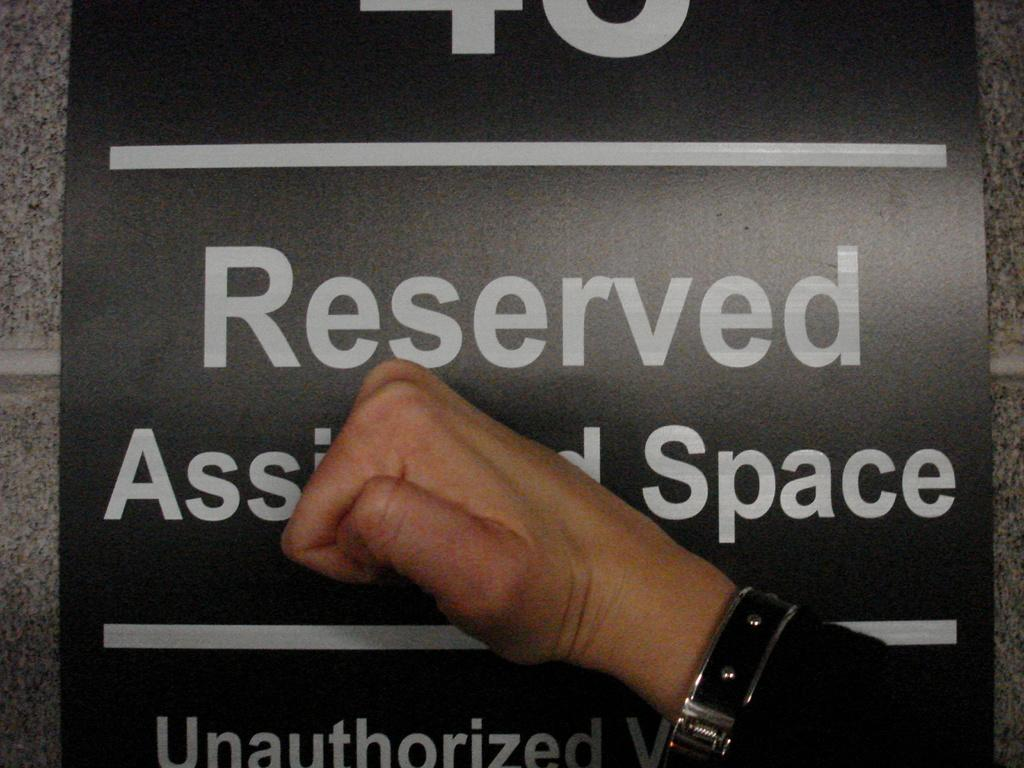Provide a one-sentence caption for the provided image. A hand clenched into a fist covering a "Reserved Space"sign. 